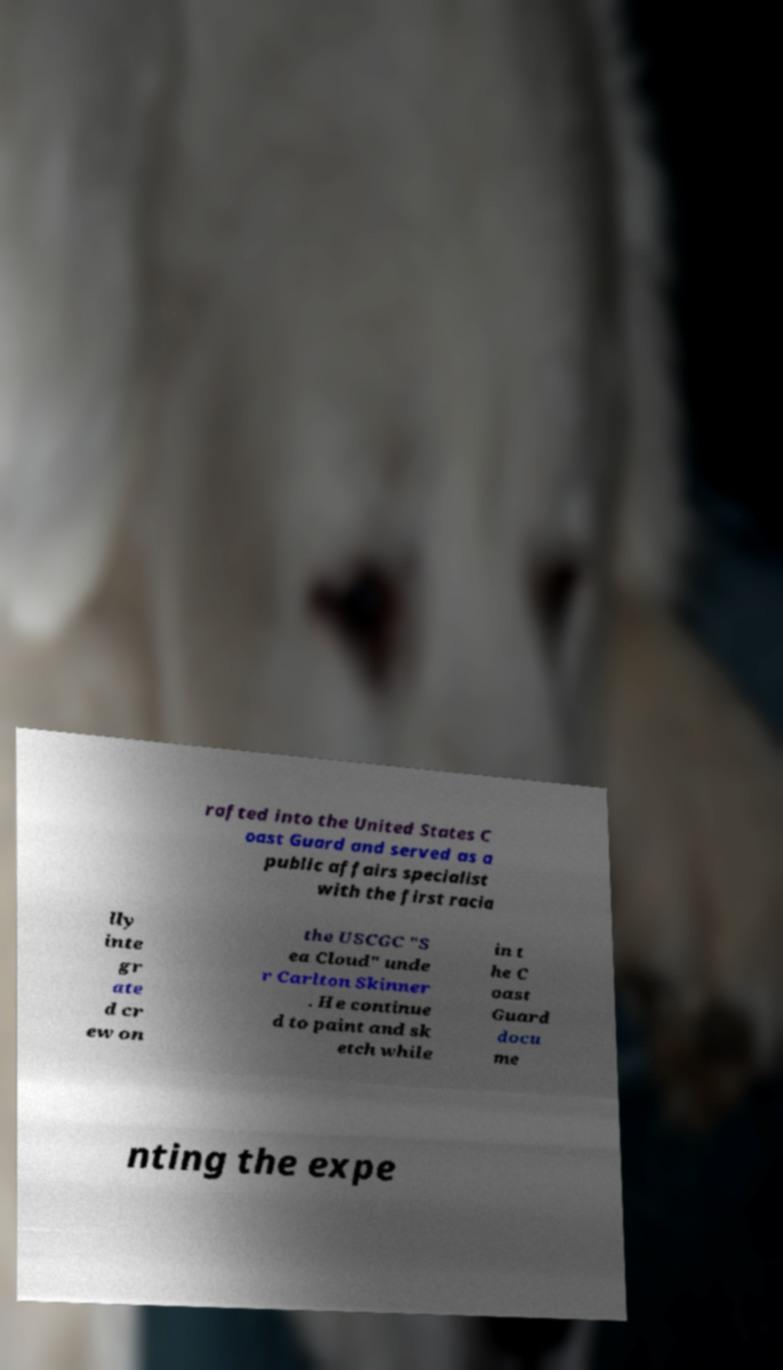Could you assist in decoding the text presented in this image and type it out clearly? rafted into the United States C oast Guard and served as a public affairs specialist with the first racia lly inte gr ate d cr ew on the USCGC "S ea Cloud" unde r Carlton Skinner . He continue d to paint and sk etch while in t he C oast Guard docu me nting the expe 